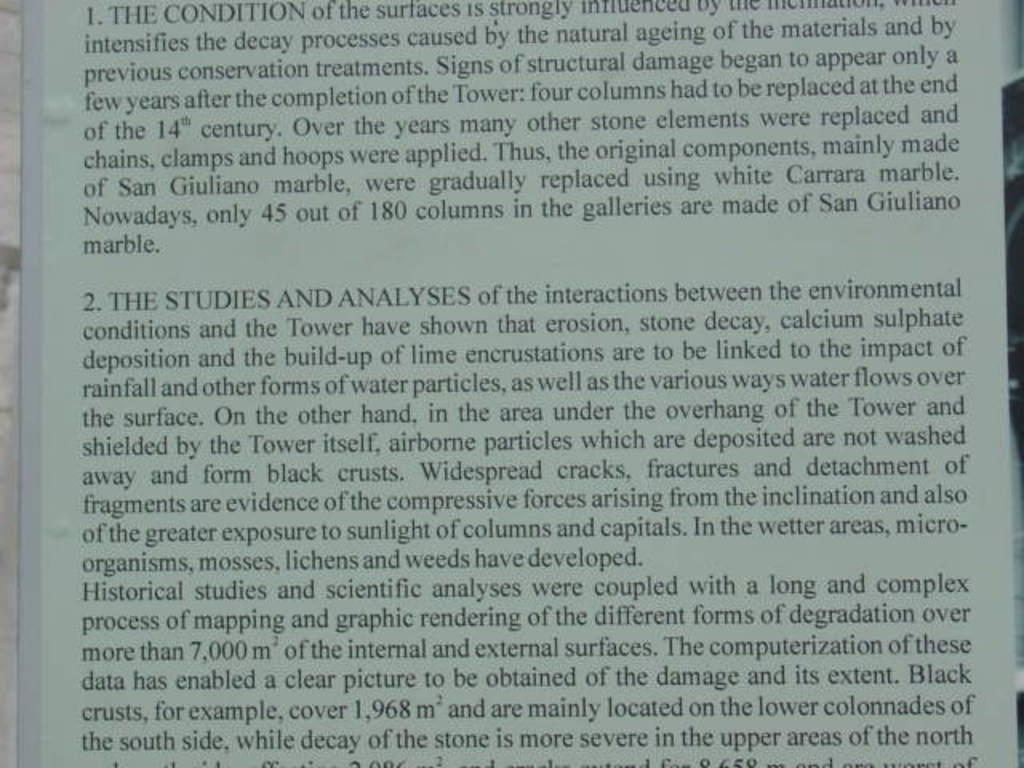<image>
Offer a succinct explanation of the picture presented. A textbook displaying information regarding scientific studies analyses 